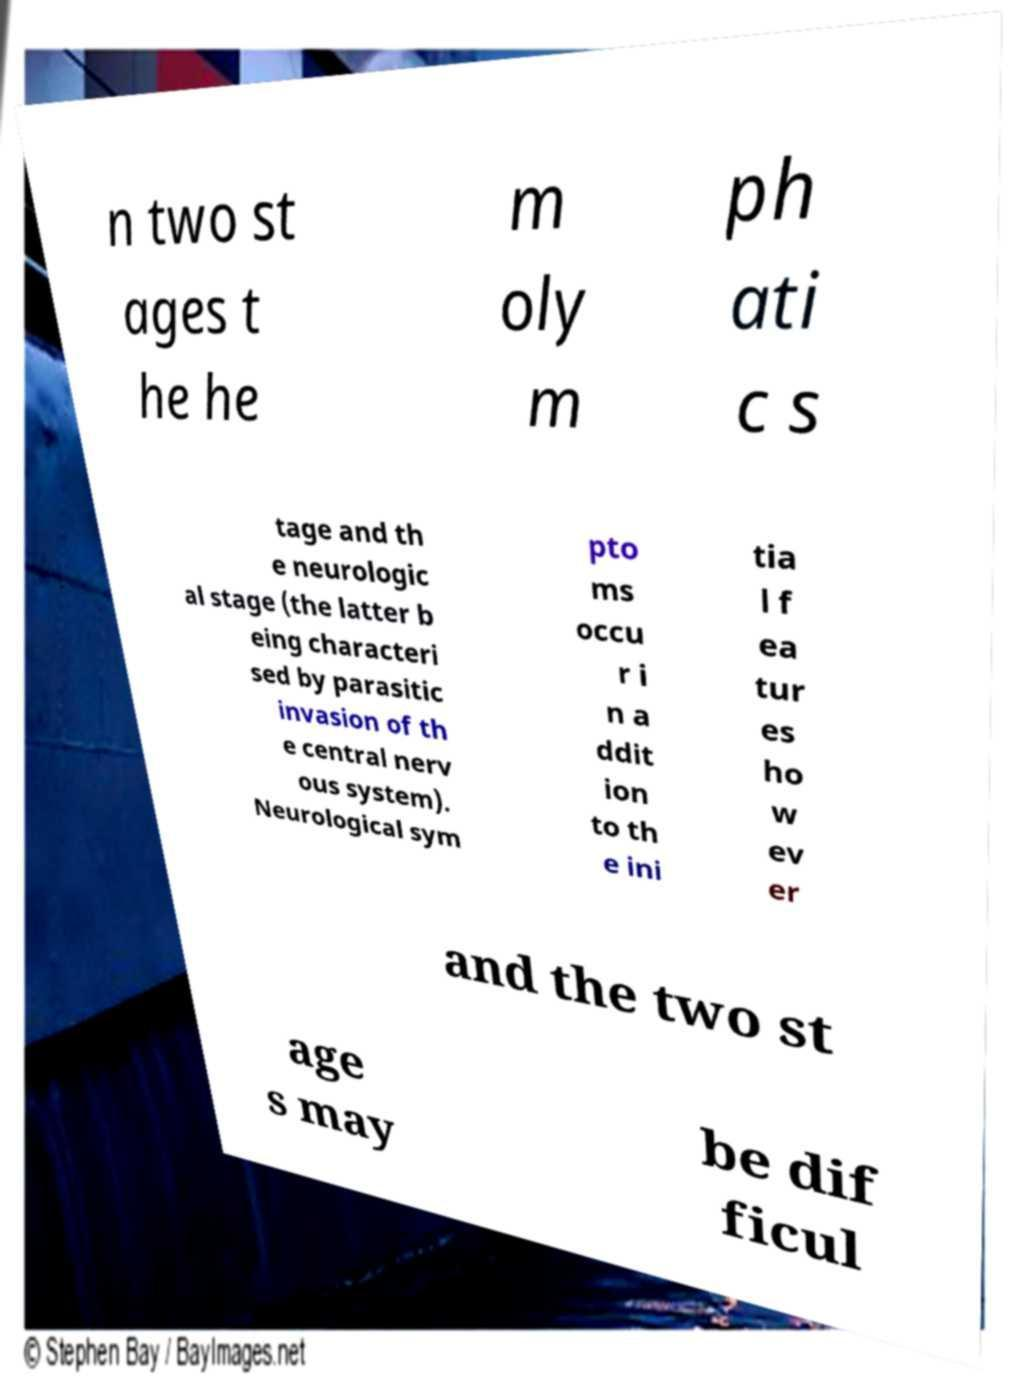Could you extract and type out the text from this image? n two st ages t he he m oly m ph ati c s tage and th e neurologic al stage (the latter b eing characteri sed by parasitic invasion of th e central nerv ous system). Neurological sym pto ms occu r i n a ddit ion to th e ini tia l f ea tur es ho w ev er and the two st age s may be dif ficul 